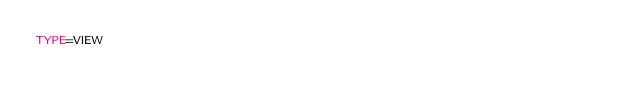<code> <loc_0><loc_0><loc_500><loc_500><_VisualBasic_>TYPE=VIEW</code> 